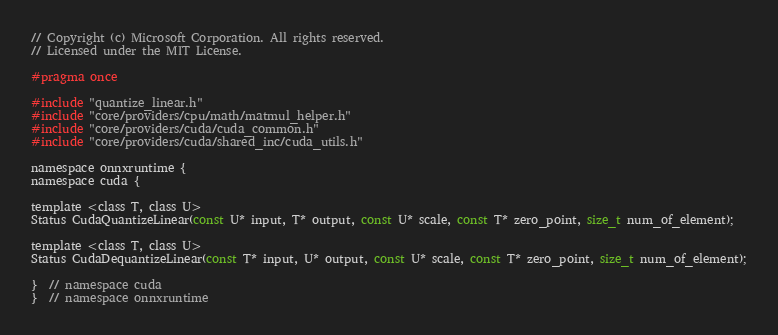Convert code to text. <code><loc_0><loc_0><loc_500><loc_500><_Cuda_>// Copyright (c) Microsoft Corporation. All rights reserved.
// Licensed under the MIT License.

#pragma once

#include "quantize_linear.h"
#include "core/providers/cpu/math/matmul_helper.h"
#include "core/providers/cuda/cuda_common.h"
#include "core/providers/cuda/shared_inc/cuda_utils.h"

namespace onnxruntime {
namespace cuda {

template <class T, class U>
Status CudaQuantizeLinear(const U* input, T* output, const U* scale, const T* zero_point, size_t num_of_element);

template <class T, class U>
Status CudaDequantizeLinear(const T* input, U* output, const U* scale, const T* zero_point, size_t num_of_element);

}  // namespace cuda
}  // namespace onnxruntime
</code> 